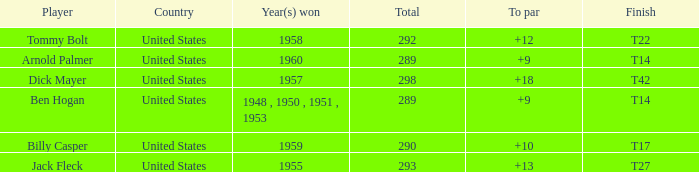What is Player, when Year(s) Won is 1955? Jack Fleck. Parse the full table. {'header': ['Player', 'Country', 'Year(s) won', 'Total', 'To par', 'Finish'], 'rows': [['Tommy Bolt', 'United States', '1958', '292', '+12', 'T22'], ['Arnold Palmer', 'United States', '1960', '289', '+9', 'T14'], ['Dick Mayer', 'United States', '1957', '298', '+18', 'T42'], ['Ben Hogan', 'United States', '1948 , 1950 , 1951 , 1953', '289', '+9', 'T14'], ['Billy Casper', 'United States', '1959', '290', '+10', 'T17'], ['Jack Fleck', 'United States', '1955', '293', '+13', 'T27']]} 